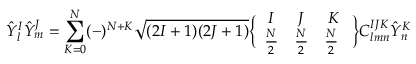Convert formula to latex. <formula><loc_0><loc_0><loc_500><loc_500>{ \hat { Y } } _ { l } ^ { I } { \hat { Y } } _ { m } ^ { J } = \sum _ { K = 0 } ^ { N } ( - ) ^ { N + K } \sqrt { ( 2 I + 1 ) ( 2 J + 1 ) } \left \{ \begin{array} { c c c } { I } & { J } & { K } \\ { { { \frac { N } { 2 } } } } & { { { \frac { N } { 2 } } } } & { { { \frac { N } { 2 } } \ } } \end{array} \right \} C _ { l m n } ^ { I J K } { \hat { Y } } _ { n } ^ { K }</formula> 